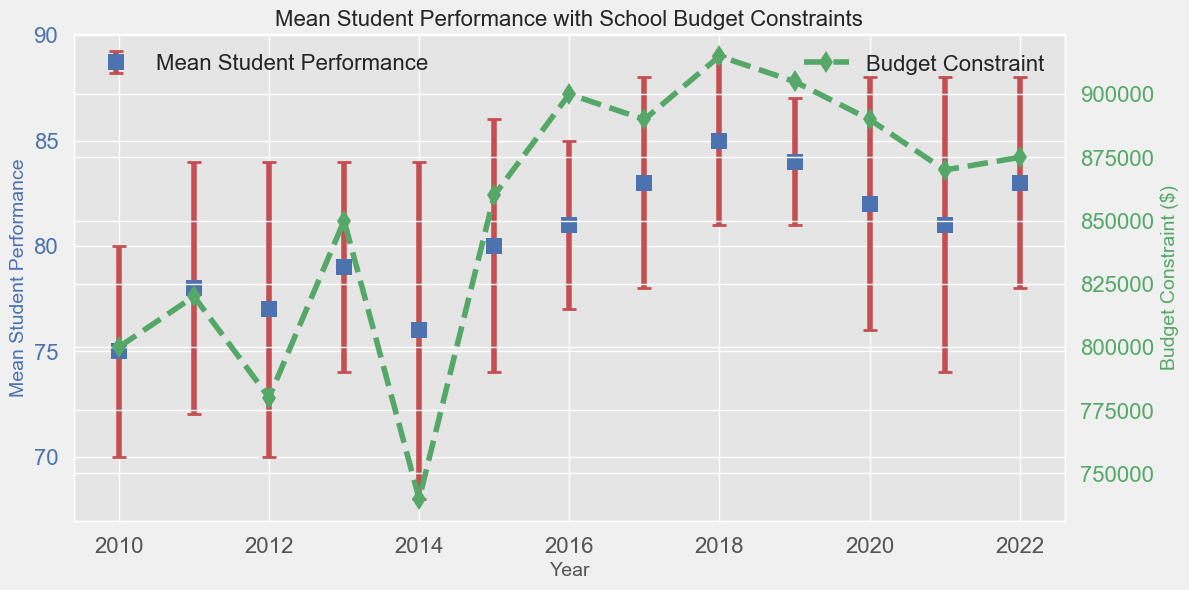What's the highest mean student performance recorded in the years shown? Look at the tallest data points on the "Mean Student Performance" axis. The highest recorded value is in the year 2018 with a mean student performance of 85.
Answer: 85 In which year did mean student performance drop despite an increased budget constraint? The year 2020 shows a drop in student performance to 82, even though the budget constraint was higher than the previous year (890,000 compared to 875,000 in 2019).
Answer: 2020 Between which two years is the biggest improvement in mean student performance? Identify the years with the greatest positive change in mean student performance. The largest improvement is from 2017 (Mean: 83) to 2018 (Mean: 85).
Answer: 2017 to 2018 What was the mean student performance in 2014 compared to 2012? Look at the data points for these two years. In 2014, it was 76, and in 2012, it was 77, showing a decline.
Answer: 2014 had lower performance Which year had the smallest error bar for mean student performance? Check the vertical lines representing the error bars and find the year with the shortest line. The smallest error bar is in 2019 with an error of 3.
Answer: 2019 What's the average mean student performance from 2016 to 2018? Calculate the mean of mean student performance values for these years: (81 + 83 + 85) / 3 = 83.
Answer: 83 How does student performance in 2022 compare to 2010? Compare the data points for these years. In 2010, the performance was 75, and in 2022, it was 83, showing an improvement.
Answer: 2022 was higher What was the budget constraint in 2015, and how did it affect student performance? In 2015, the budget was 860,000, and the student performance was 80, indicating a positive correlation between a higher budget and better performance.
Answer: Budget: 860,000, Performance: 80 Was there any year where the mean student performance was exactly equal to the budget constraint divided by 10,000? Divide the budget for each year by 10,000 and compare it to the student performance. In 2013, the budget was 850,000, so 850,000 / 10,000 = 85, matching the performance for 2018.
Answer: No 